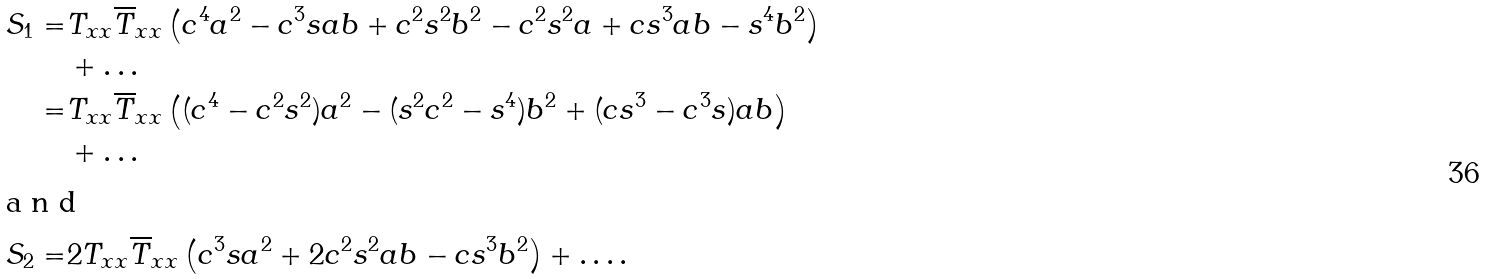Convert formula to latex. <formula><loc_0><loc_0><loc_500><loc_500>S _ { 1 } = & T _ { x x } \overline { T } _ { x x } \left ( c ^ { 4 } a ^ { 2 } - c ^ { 3 } s a b + c ^ { 2 } s ^ { 2 } b ^ { 2 } - c ^ { 2 } s ^ { 2 } a + c s ^ { 3 } a b - s ^ { 4 } b ^ { 2 } \right ) \\ & + \dots \\ = & T _ { x x } \overline { T } _ { x x } \left ( ( c ^ { 4 } - c ^ { 2 } s ^ { 2 } ) a ^ { 2 } - ( s ^ { 2 } c ^ { 2 } - s ^ { 4 } ) b ^ { 2 } + ( c s ^ { 3 } - c ^ { 3 } s ) a b \right ) \\ & + \dots \\ \intertext { a n d } S _ { 2 } = & 2 T _ { x x } \overline { T } _ { x x } \left ( c ^ { 3 } s a ^ { 2 } + 2 c ^ { 2 } s ^ { 2 } a b - c s ^ { 3 } b ^ { 2 } \right ) + \dots .</formula> 